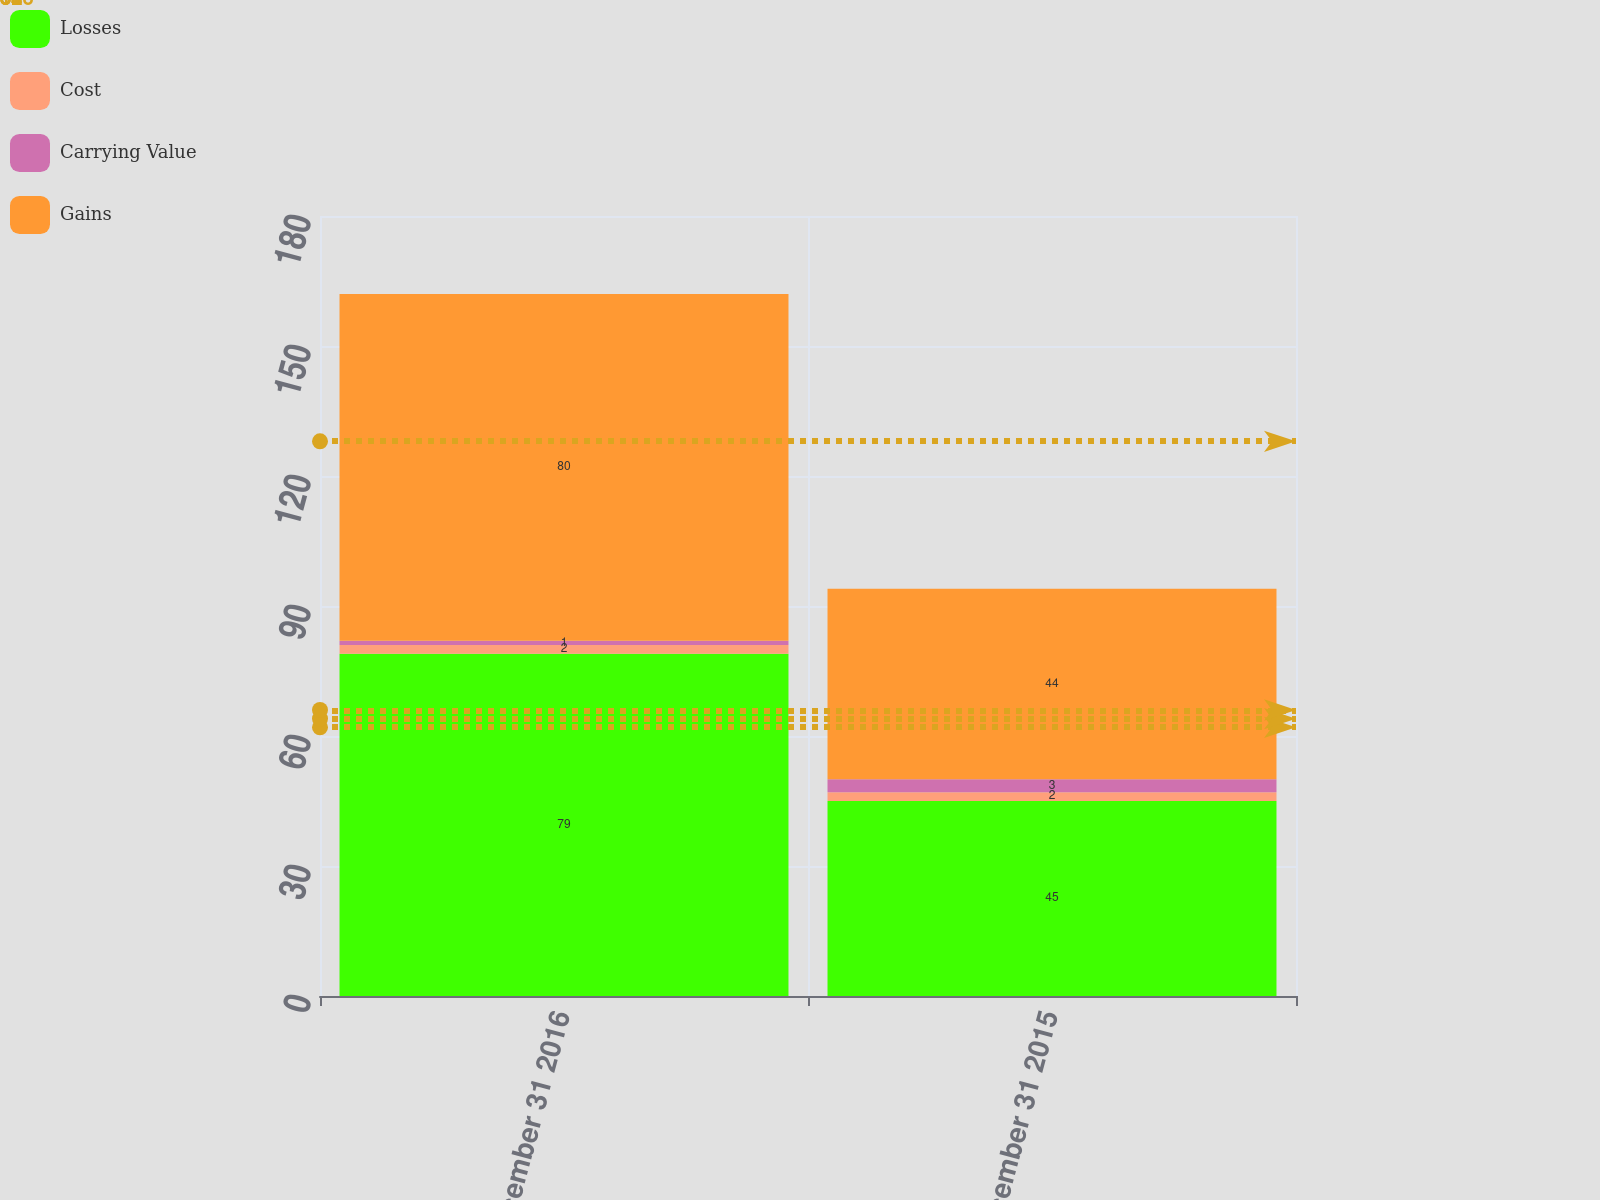<chart> <loc_0><loc_0><loc_500><loc_500><stacked_bar_chart><ecel><fcel>December 31 2016<fcel>December 31 2015<nl><fcel>Losses<fcel>79<fcel>45<nl><fcel>Cost<fcel>2<fcel>2<nl><fcel>Carrying Value<fcel>1<fcel>3<nl><fcel>Gains<fcel>80<fcel>44<nl></chart> 